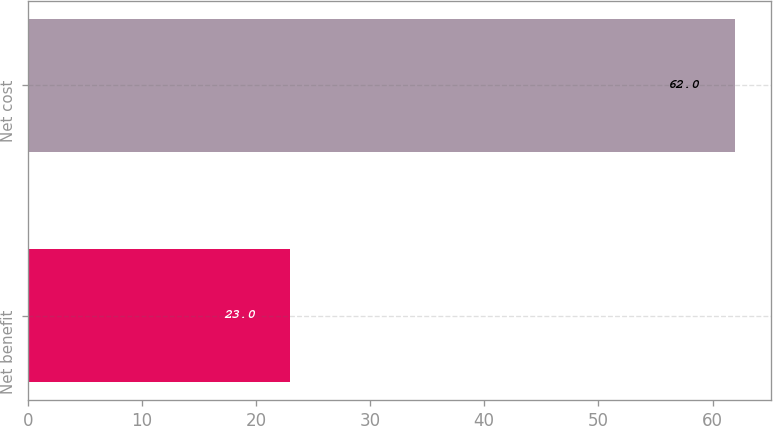<chart> <loc_0><loc_0><loc_500><loc_500><bar_chart><fcel>Net benefit<fcel>Net cost<nl><fcel>23<fcel>62<nl></chart> 